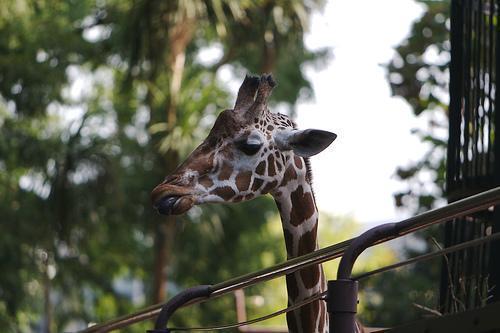How many giraffes are in this photo?
Give a very brief answer. 1. 